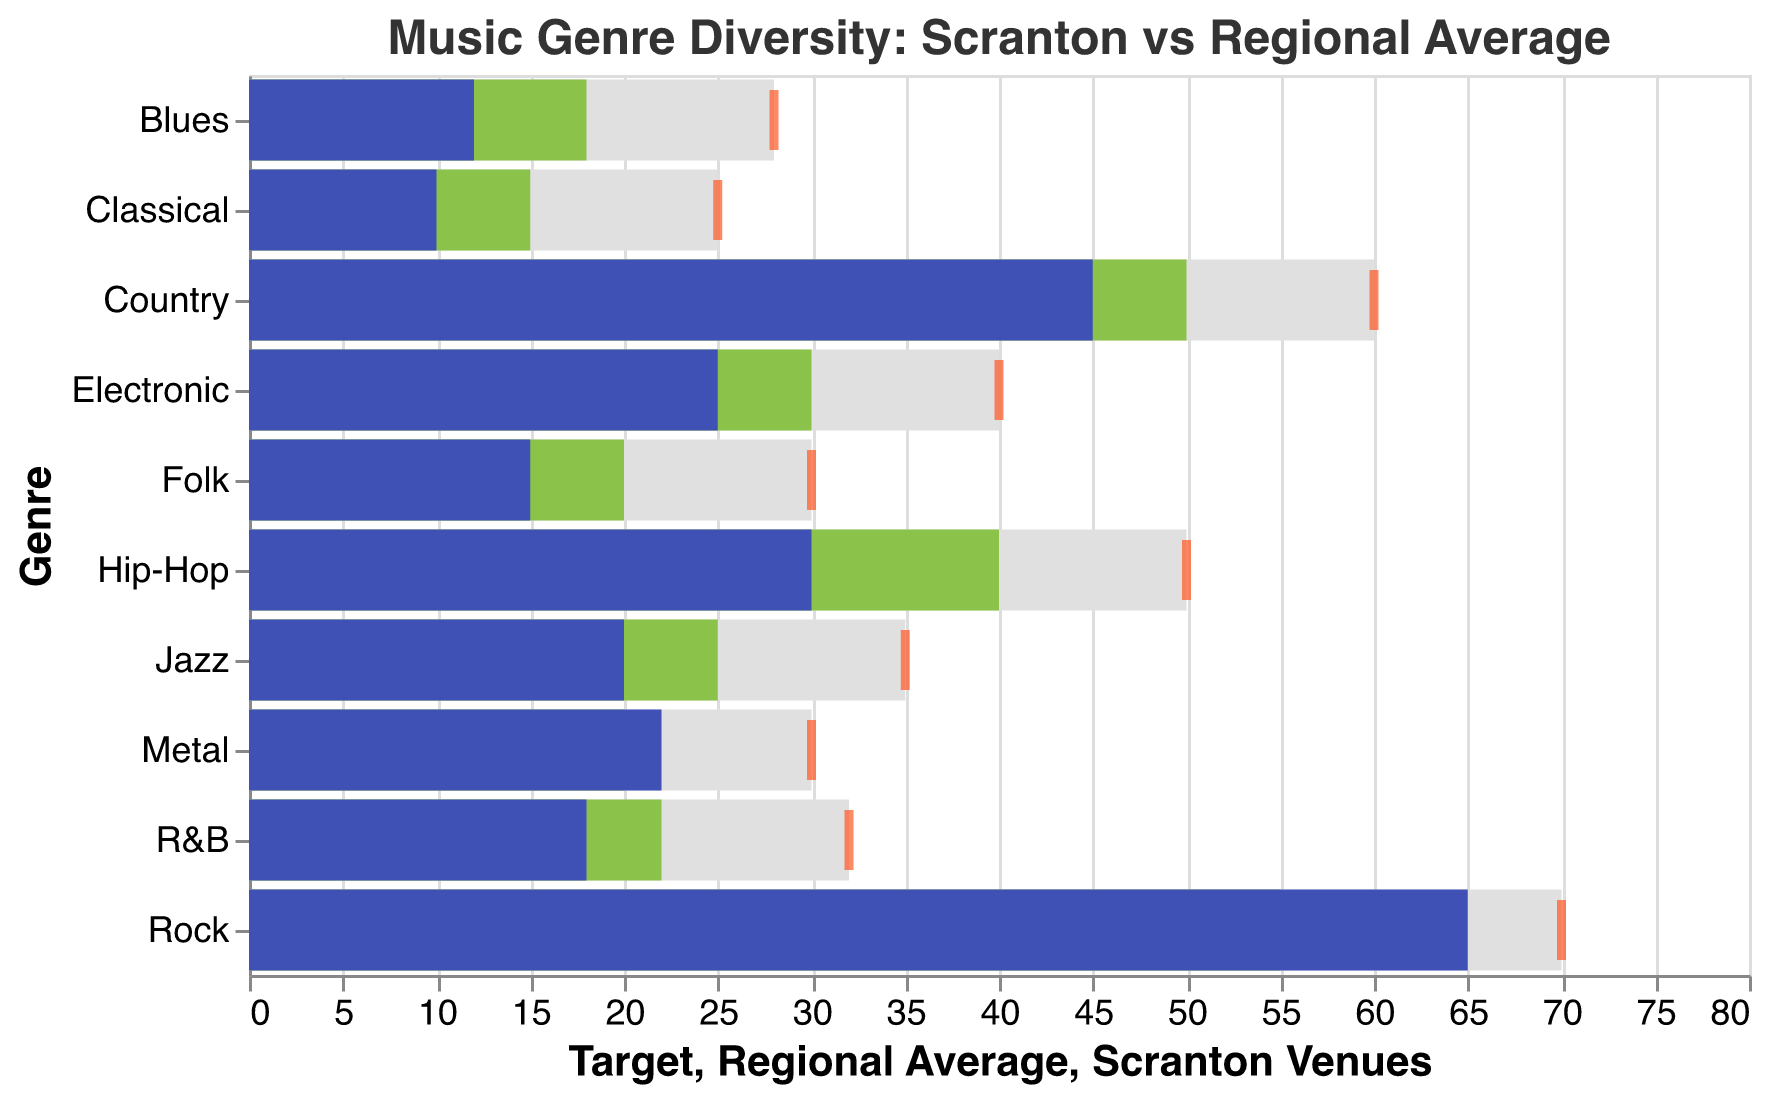What's the title of the chart? Look at the top center part of the chart to find the title text.
Answer: Music Genre Diversity: Scranton vs Regional Average What color represents the Scranton Venues bar in the chart? Scranton Venues bars are consistently represented by a single color throughout the chart.
Answer: Blue For which genre is the Scranton Venues count closest to its Target? Compare the differences between the Scranton Venues bar and the Target tick for each genre.
Answer: Rock Which genre in Scranton has a higher venue count than the Regional Average? Look at each genre and compare the heights of the Scranton Venues bar and the Regional Average bar, noting genres where Scranton Venues is higher.
Answer: Rock, Metal Which genre has the largest difference between the Scranton Venues count and the Regional Average? Calculate the differences for each genre and determine which has the largest value. Rock: 10, Country: -5, Hip-Hop: -10, Jazz: -5, Electronic: -5, Folk: -5, Classical: -5, Blues: -6, R&B: -4, Metal: 2
Answer: Hip-Hop What's the aggregate total of the Scranton Venues counts for all genres? Add up all the values for Scranton Venues across all genres. 65 + 45 + 30 + 20 + 25 + 15 + 10 + 12 + 18 + 22 = 262
Answer: 262 Does any genre in Scranton exceed the Target, and if so, which one(s)? Compare each Scranton Venues bar with the corresponding Target tick to see if any exceed.
Answer: None What's the average target value across all genres? Add up all the Target values and divide by the number of genres: (70 + 60 + 50 + 35 + 40 + 30 + 25 + 28 + 32 + 30) / 10 = 40
Answer: 40 How does the R&B venue count in Scranton compare to its Regional Average? Look at the respective bars for R&B and compare their lengths.
Answer: Less 